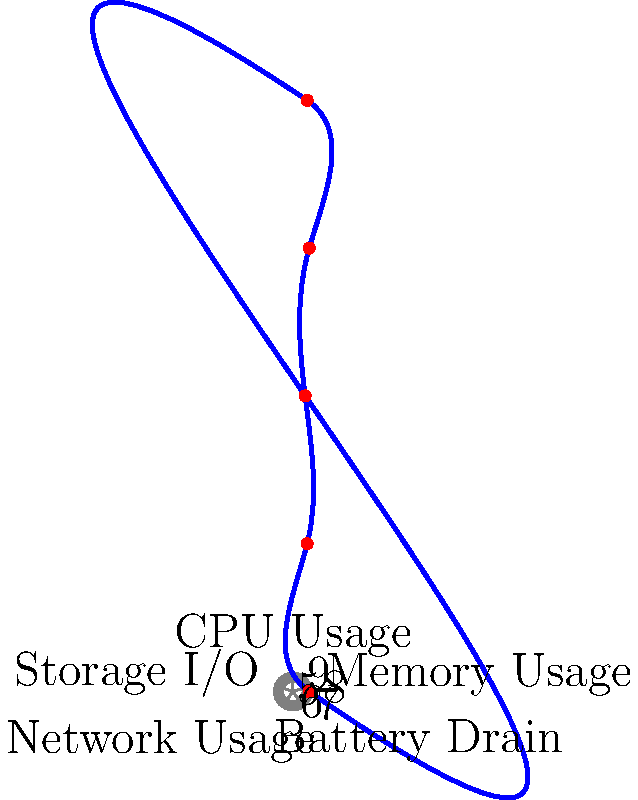A radar chart is used to visualize the performance metrics of an Android app. The chart shows five metrics: CPU Usage, Memory Usage, Battery Drain, Network Usage, and Storage I/O. Each metric is represented on a scale from 0 to 9. If the app's performance data points form a regular pentagon, what would be the area of this pentagon? To solve this problem, we'll follow these steps:

1) First, we need to understand that a regular pentagon in a radar chart would mean all metrics have the same value. Let's assume this value is $r$.

2) The area of a regular pentagon can be calculated using the formula:

   $$A = \frac{5r^2}{4} \tan(36°)$$

   Where $r$ is the distance from the center to any vertex (which represents our metric value).

3) We need to determine $r$. Looking at the chart, we can see that the scale goes from 0 to 9. A balanced app performance would likely be around the middle of this range, so let's estimate $r = 5$.

4) Now we can plug this into our formula:

   $$A = \frac{5(5^2)}{4} \tan(36°)$$

5) Simplify:
   
   $$A = \frac{125}{4} \tan(36°)$$

6) Calculate:
   
   $$A \approx 31.25 \tan(36°) \approx 22.48$$

7) Since we're dealing with app performance metrics, which don't have a specific unit in this context, we can round this to 22.5 square units.
Answer: 22.5 square units 